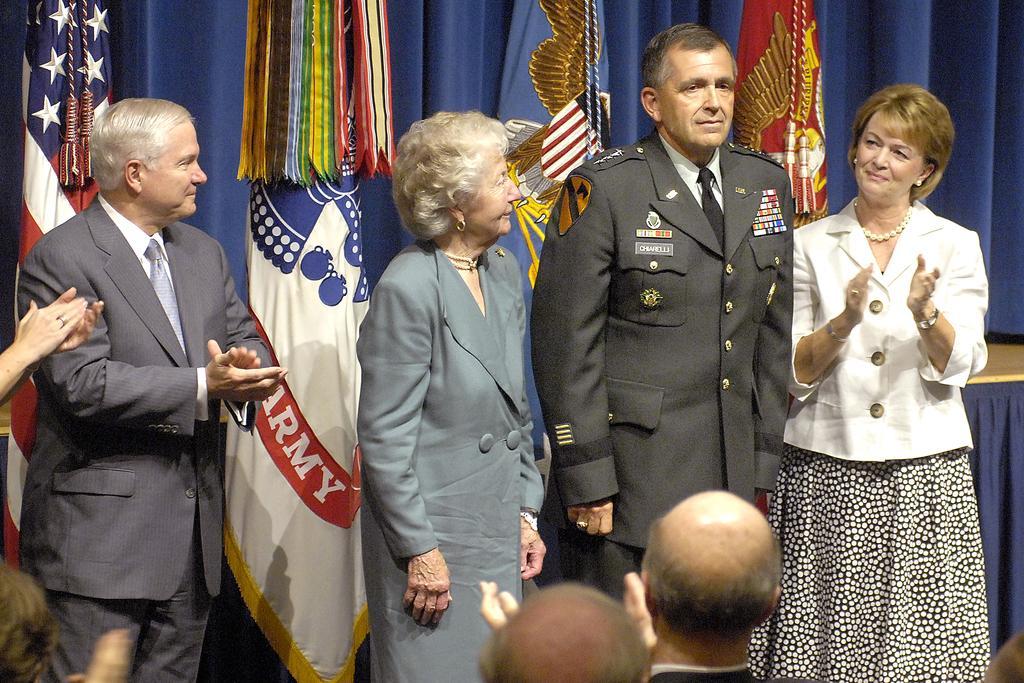Can you describe this image briefly? In the center of the image, we can see a man and a lady standing and in the background, there are some other people clapping hands and we can see flags. 